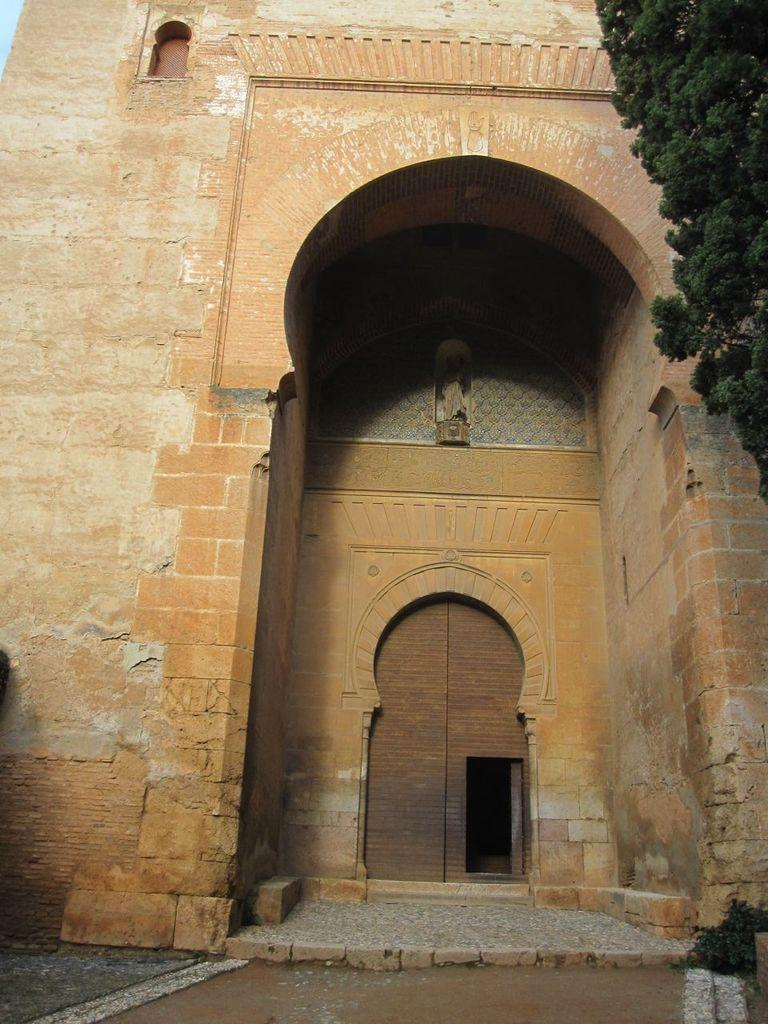What type of structure is visible in the image? There is a building in the image. What feature of the building is mentioned in the facts? The building has a door. What type of vegetation is on the right side of the image? There is a tree on the right side of the image. What color is the hair on the tree in the image? There is no hair present on the tree in the image, as trees do not have hair. 